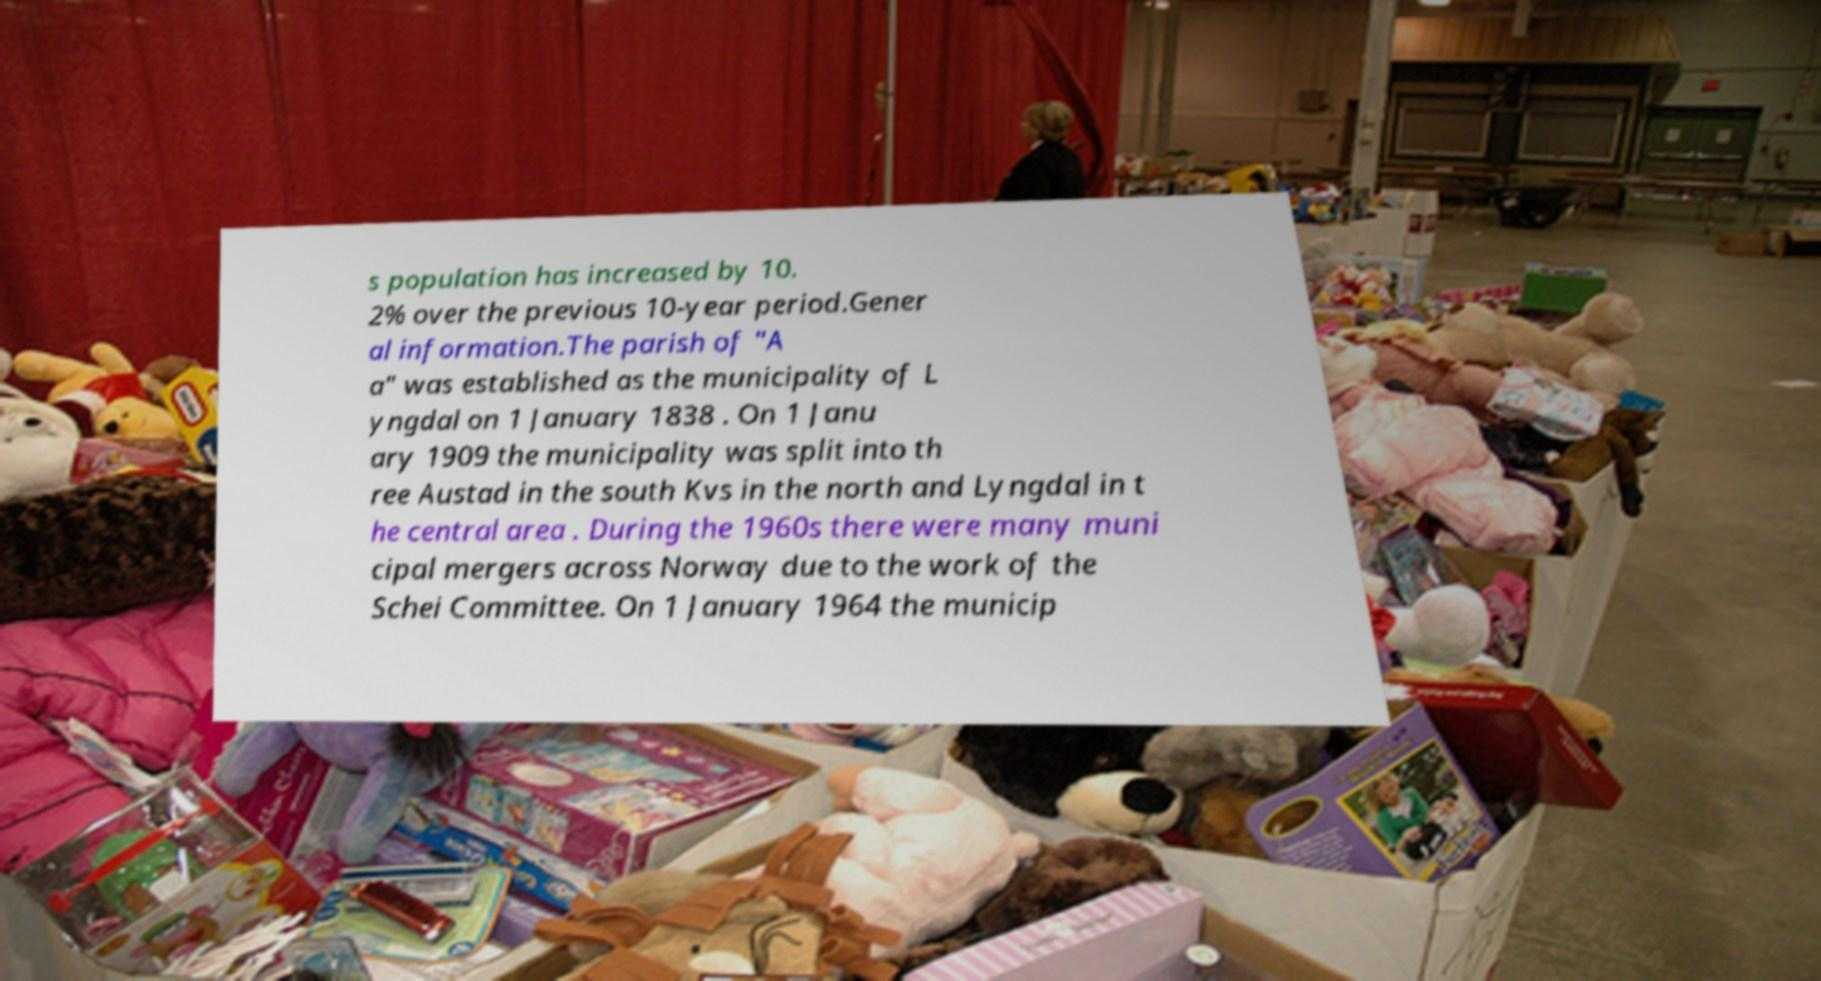For documentation purposes, I need the text within this image transcribed. Could you provide that? s population has increased by 10. 2% over the previous 10-year period.Gener al information.The parish of "A a" was established as the municipality of L yngdal on 1 January 1838 . On 1 Janu ary 1909 the municipality was split into th ree Austad in the south Kvs in the north and Lyngdal in t he central area . During the 1960s there were many muni cipal mergers across Norway due to the work of the Schei Committee. On 1 January 1964 the municip 